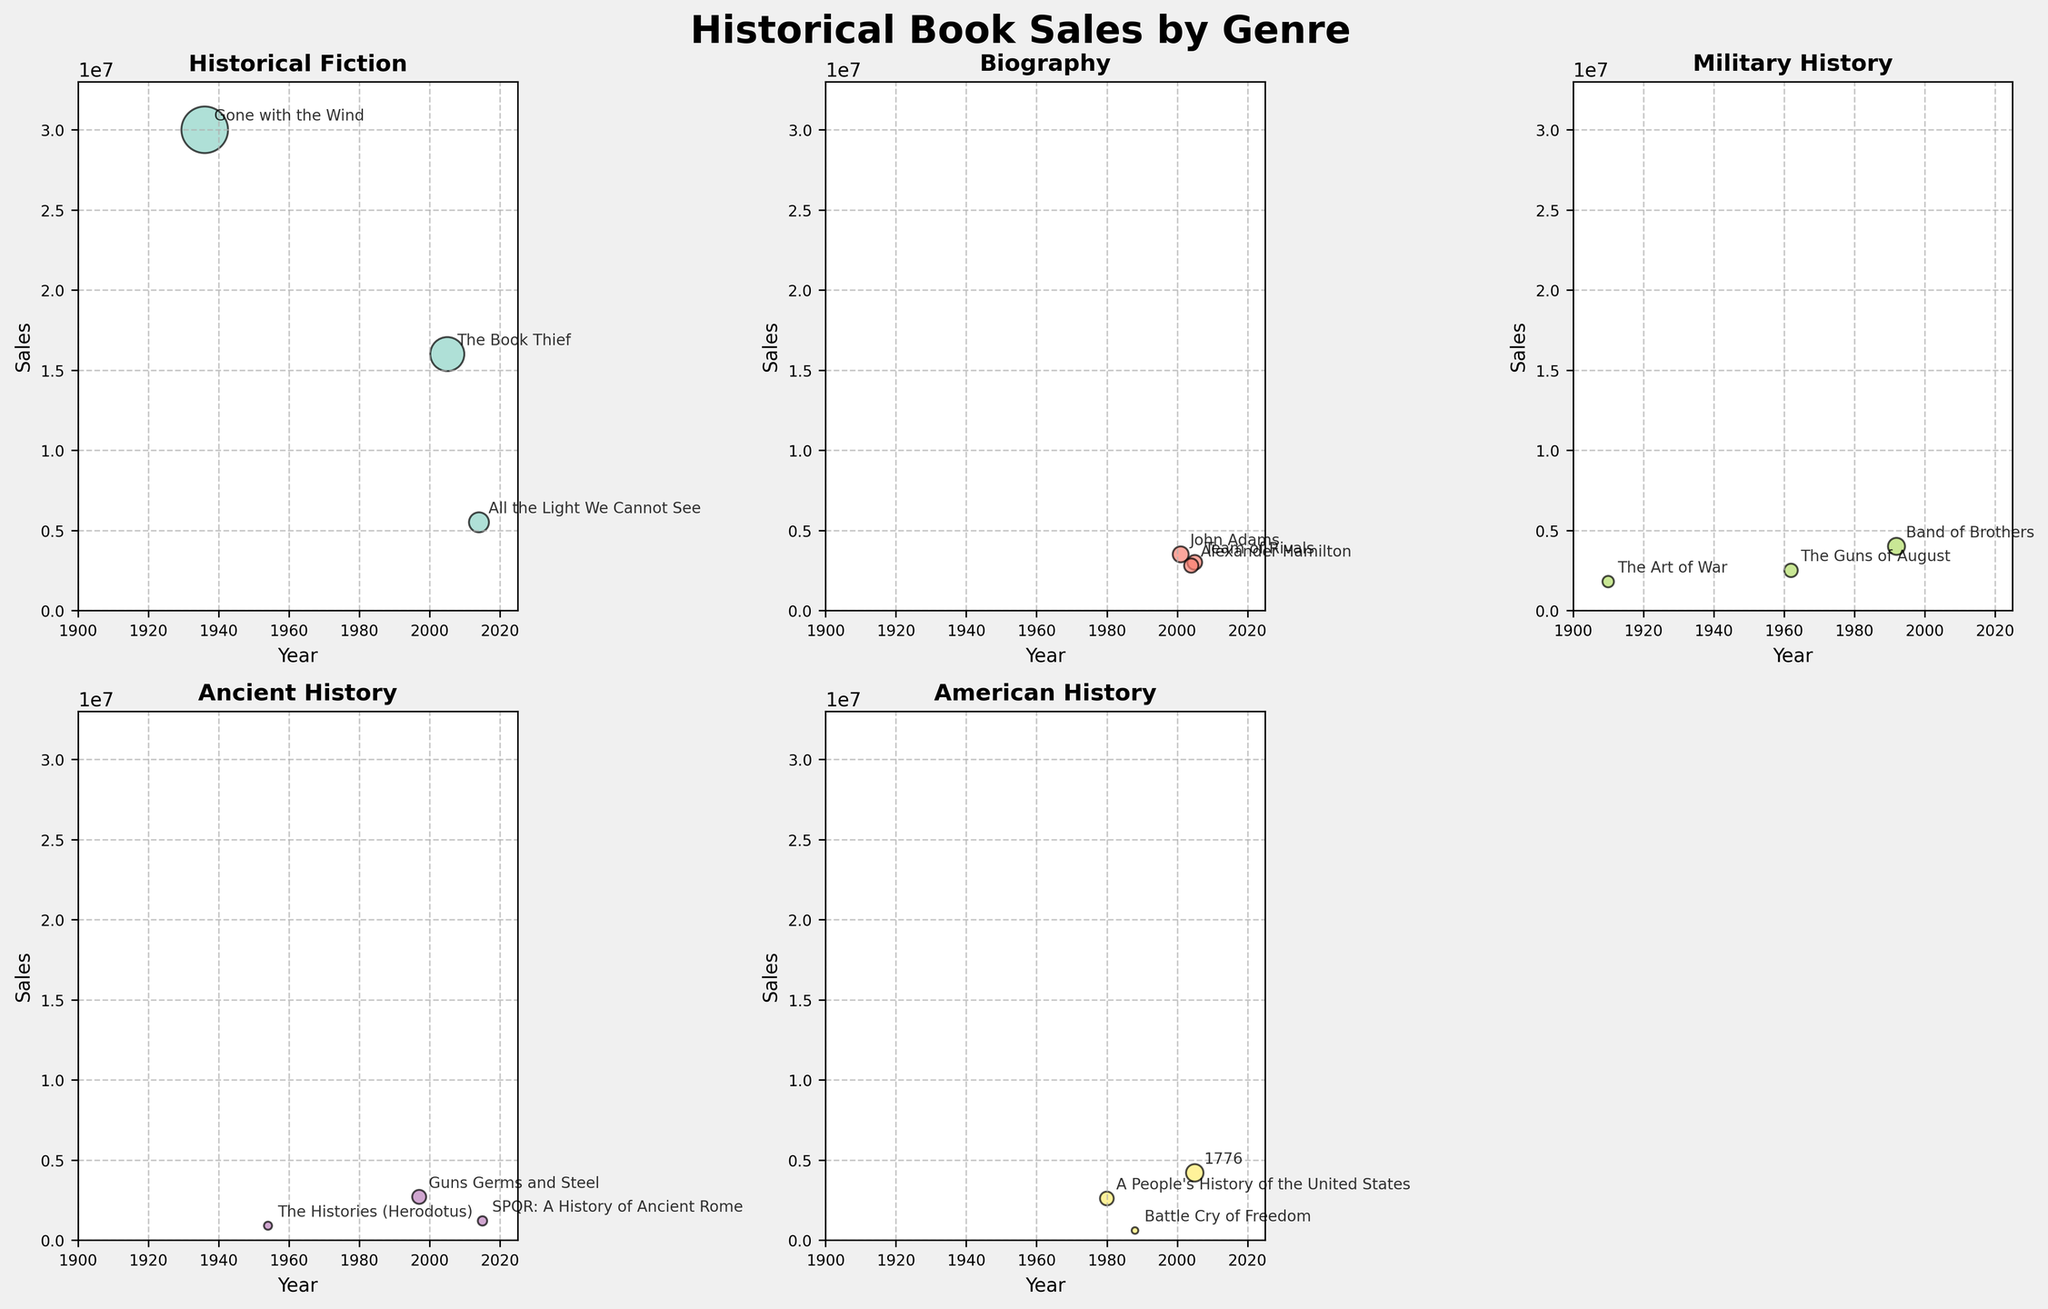Which genre has the book with the highest sales? The scatter plot for Historical Fiction shows the book "Gone with the Wind" in 1936 with sales of 30,000,000, which is the highest on all plots.
Answer: Historical Fiction How many genres are represented in the plots? There are six subplots, each titled with a different genre: Historical Fiction, Biography, Military History, Ancient History, and American History. The last subplot is empty, so there are 5 genres represented.
Answer: 5 What is the latest year with a book sale data point in the Biography genre? In the Biography genre subplot, the latest year shown is 2005 with the book "Team of Rivals".
Answer: 2005 Which genre has the least sales for any single book, and what is that book? The subplot for Ancient History shows "The Histories (Herodotus)" in 1954 with 900,000 sales, which is the lowest individual sales among all books.
Answer: Ancient History, The Histories (Herodotus) Compare the sales of "The Art of War" and "Band of Brothers" in Military History. Which has higher sales and by how much? In the Military History subplot, "Band of Brothers" in 1992 has 4,000,000 sales, and "The Art of War" in 1910 has 1,800,000 sales. The difference is 4,000,000 - 1,800,000 = 2,200,000.
Answer: Band of Brothers, 2,200,000 Between "1776" and "A People's History of the United States" in American History, which book has more sales and by how much? "1776" in 2005 has sales of 4,200,000, whereas "A People's History of the United States" in 1980 has sales of 2,600,000. The difference is 4,200,000 - 2,600,000 = 1,600,000.
Answer: 1776, 1,600,000 What is the average sales of books in the Ancient History category? The sales for Ancient History are: "SPQR: A History of Ancient Rome" - 1,200,000, "Guns Germs and Steel" - 2,700,000, "The Histories (Herodotus)" - 900,000. The average is (1,200,000 + 2,700,000 + 900,000) / 3 = 1,600,000.
Answer: 1,600,000 Which book in Biography has the closest sales to 3,000,000? In the Biography subplot, "Team of Rivals" has sales of 3,000,000, which matches exactly.
Answer: Team of Rivals Which genre's subplot has the widest year range (difference between the oldest and most recent years)? Historical Fiction ranges from 1936 to 2014 (78 years), Biography from 2001 to 2005 (4 years), Military History from 1910 to 1992 (82 years), Ancient History from 1954 to 2015 (61 years), and American History from 1980 to 2005 (25 years). Military History has the widest range of 82 years.
Answer: Military History Which genre contains the book with the second-highest sales, and what is that book? In the Historical Fiction subplot, "The Book Thief" in 2005 has the second-highest sales of 16,000,000, following "Gone with the Wind".
Answer: Historical Fiction, The Book Thief 